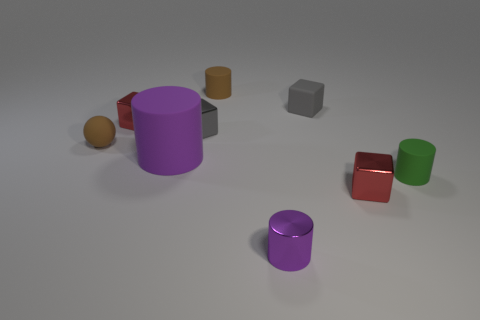There is a red object to the left of the small rubber block; what is it made of?
Your answer should be very brief. Metal. Are the tiny block that is on the left side of the tiny gray metal block and the purple object in front of the green thing made of the same material?
Keep it short and to the point. Yes. Is the number of small brown cylinders right of the green rubber cylinder the same as the number of things behind the large rubber object?
Offer a terse response. No. What number of brown objects have the same material as the tiny brown sphere?
Your answer should be very brief. 1. What is the shape of the tiny rubber thing that is the same color as the small rubber sphere?
Offer a very short reply. Cylinder. There is a purple cylinder left of the brown rubber cylinder right of the purple matte cylinder; what is its size?
Make the answer very short. Large. Does the small metallic object that is right of the small purple shiny object have the same shape as the small gray matte object right of the large rubber object?
Offer a very short reply. Yes. Are there the same number of gray metal things that are on the right side of the small brown cylinder and large cyan spheres?
Provide a succinct answer. Yes. The other small matte thing that is the same shape as the green thing is what color?
Your answer should be compact. Brown. Do the red cube to the right of the purple metal thing and the big purple object have the same material?
Ensure brevity in your answer.  No. 